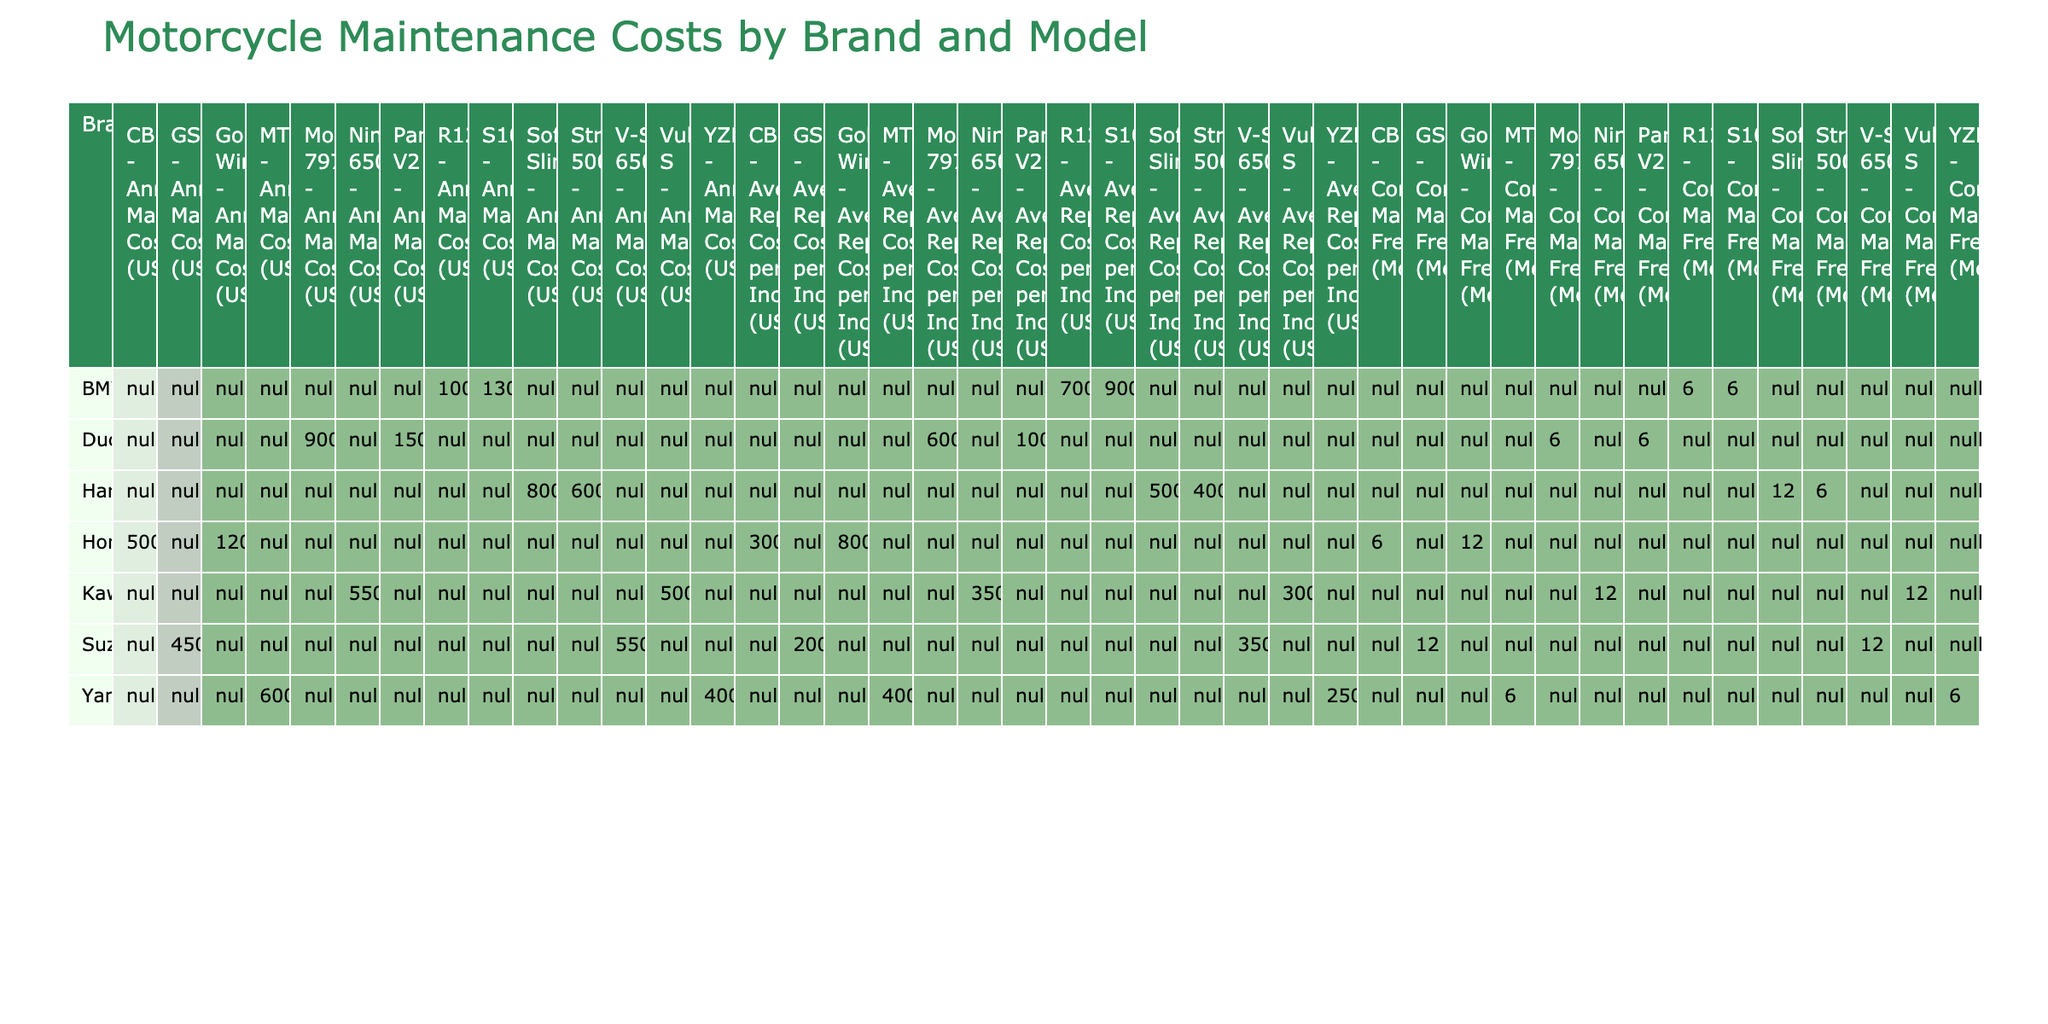What is the annual maintenance cost for the Ducati Pannigale V2? The table lists the annual maintenance cost under the Ducati brand and Pannigale V2 model, which shows 1500 USD.
Answer: 1500 USD Which brand has the highest average repair cost per incident? By examining the average repair costs for each brand, we can see that the highest amount is from Ducati with 900 USD for the S1000RR and 1000 USD for the Pannigale V2, both are higher than any other brands.
Answer: Ducati What is the average annual maintenance cost for Yamaha motorcycles? The Yamaha brand has two models listed: YZF-R3 (400 USD) and MT-09 (600 USD). The average is calculated as (400 + 600) / 2 = 500.
Answer: 500 USD Is the common maintenance frequency for the Honda Gold Wing greater than that of the Harley-Davidson Softail Slim? The Honda Gold Wing has a maintenance frequency of 12 months, while the Harley-Davidson Softail Slim has a maintenance frequency of 12 months as well. Therefore, they are equal, not greater.
Answer: No What is the combined annual maintenance cost of all Kawasaki models? The Kawasaki models are Ninja 650 (550 USD) and Vulcan S (500 USD). Adding these together, we get 550 + 500 = 1050 USD.
Answer: 1050 USD Which motorcycle model has the lowest annual maintenance cost? By reviewing the annual maintenance costs listed, the lowest value is for the Yamaha YZF-R3 at 400 USD.
Answer: Yamaha YZF-R3 Are Harley-Davidson models generally more expensive to maintain than Suzuki models? The average annual maintenance cost for Harley-Davidson models (600 + 800) / 2 = 700, and for Suzuki models (450 + 550) / 2 = 500. Since 700 is greater than 500, we conclude that Harley-Davidson models are more expensive.
Answer: Yes What is the difference in the average repair costs between Yamaha and BMW motorcycles? For Yamaha, the average repair cost is (250 + 400) / 2 = 325, and for BMW, it is (700 + 900) / 2 = 800. The difference is 800 - 325 = 475.
Answer: 475 USD 